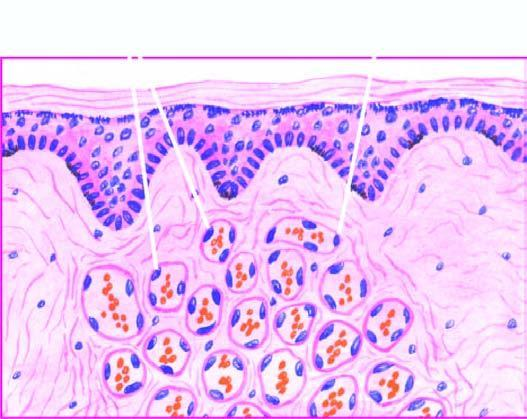re the particle capillaries lined by plump endothelial cells and containing blood?
Answer the question using a single word or phrase. No 